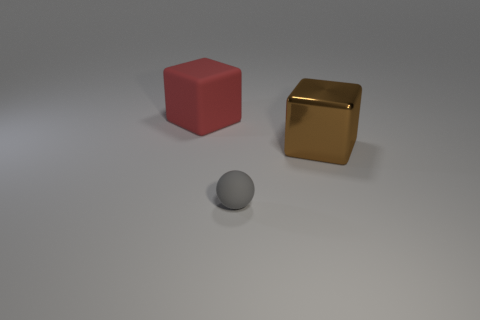What materials do the objects in the image appear to be made of? The cube on the right appears to have a metallic finish, indicative of a metal material, while the cube on the left has a matte finish, which could be plastic or wood. The sphere in the foreground has a matte surface as well and could be made of a material like stone or clay. 